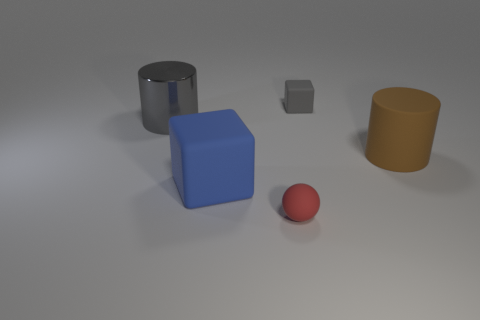Add 3 small gray cubes. How many objects exist? 8 Subtract all blocks. How many objects are left? 3 Add 4 big matte cubes. How many big matte cubes exist? 5 Subtract 0 yellow spheres. How many objects are left? 5 Subtract all tiny gray rubber things. Subtract all gray metallic cylinders. How many objects are left? 3 Add 1 large blue matte cubes. How many large blue matte cubes are left? 2 